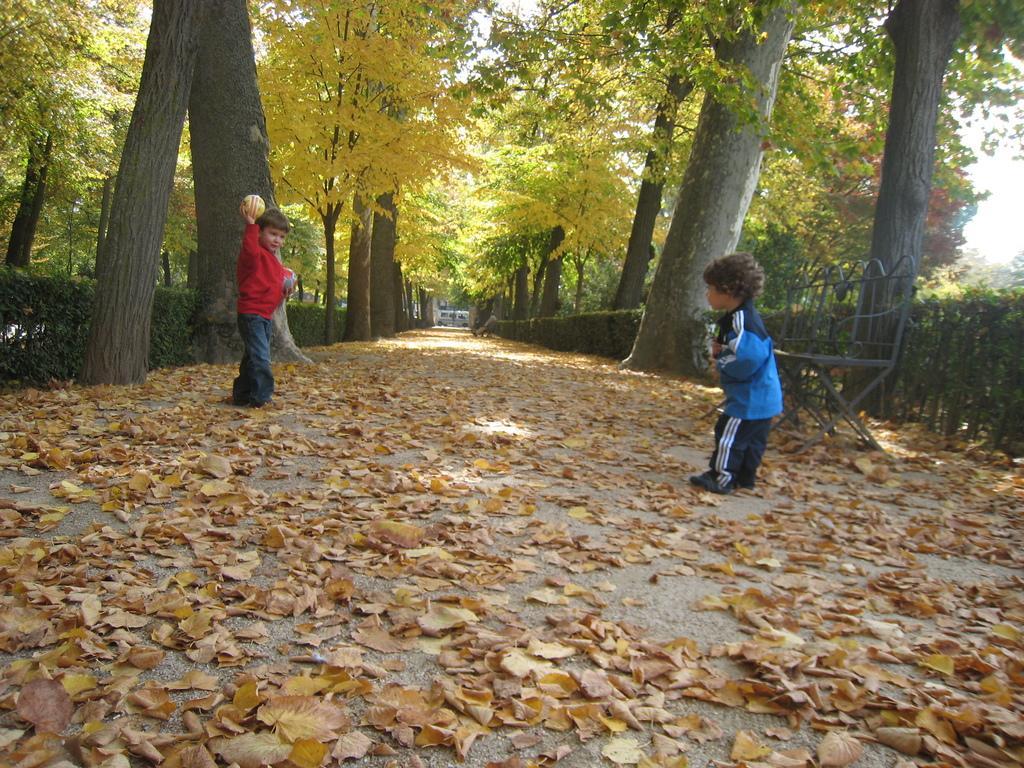Can you describe this image briefly? In this image there are two kids standing on the land having dried leaves. Left side there is a kid holding the balls. Right side there is a bench. Background there are plants and trees. Middle of the image there is a vehicle. Right side there is sky. 